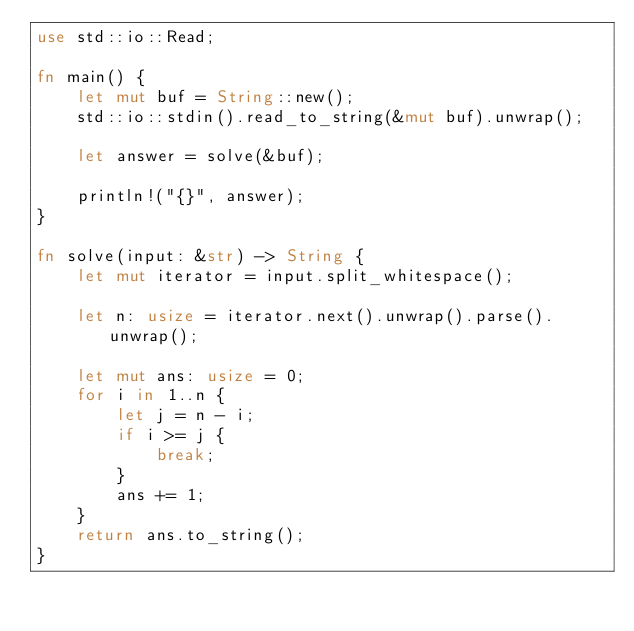Convert code to text. <code><loc_0><loc_0><loc_500><loc_500><_Rust_>use std::io::Read;

fn main() {
    let mut buf = String::new();
    std::io::stdin().read_to_string(&mut buf).unwrap();

    let answer = solve(&buf);

    println!("{}", answer);
}

fn solve(input: &str) -> String {
    let mut iterator = input.split_whitespace();

    let n: usize = iterator.next().unwrap().parse().unwrap();

    let mut ans: usize = 0;
    for i in 1..n {
        let j = n - i;
        if i >= j {
            break;
        }
        ans += 1;
    }
    return ans.to_string();
}
</code> 